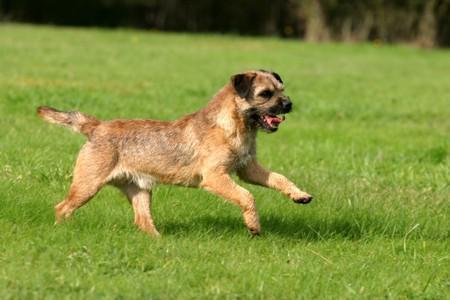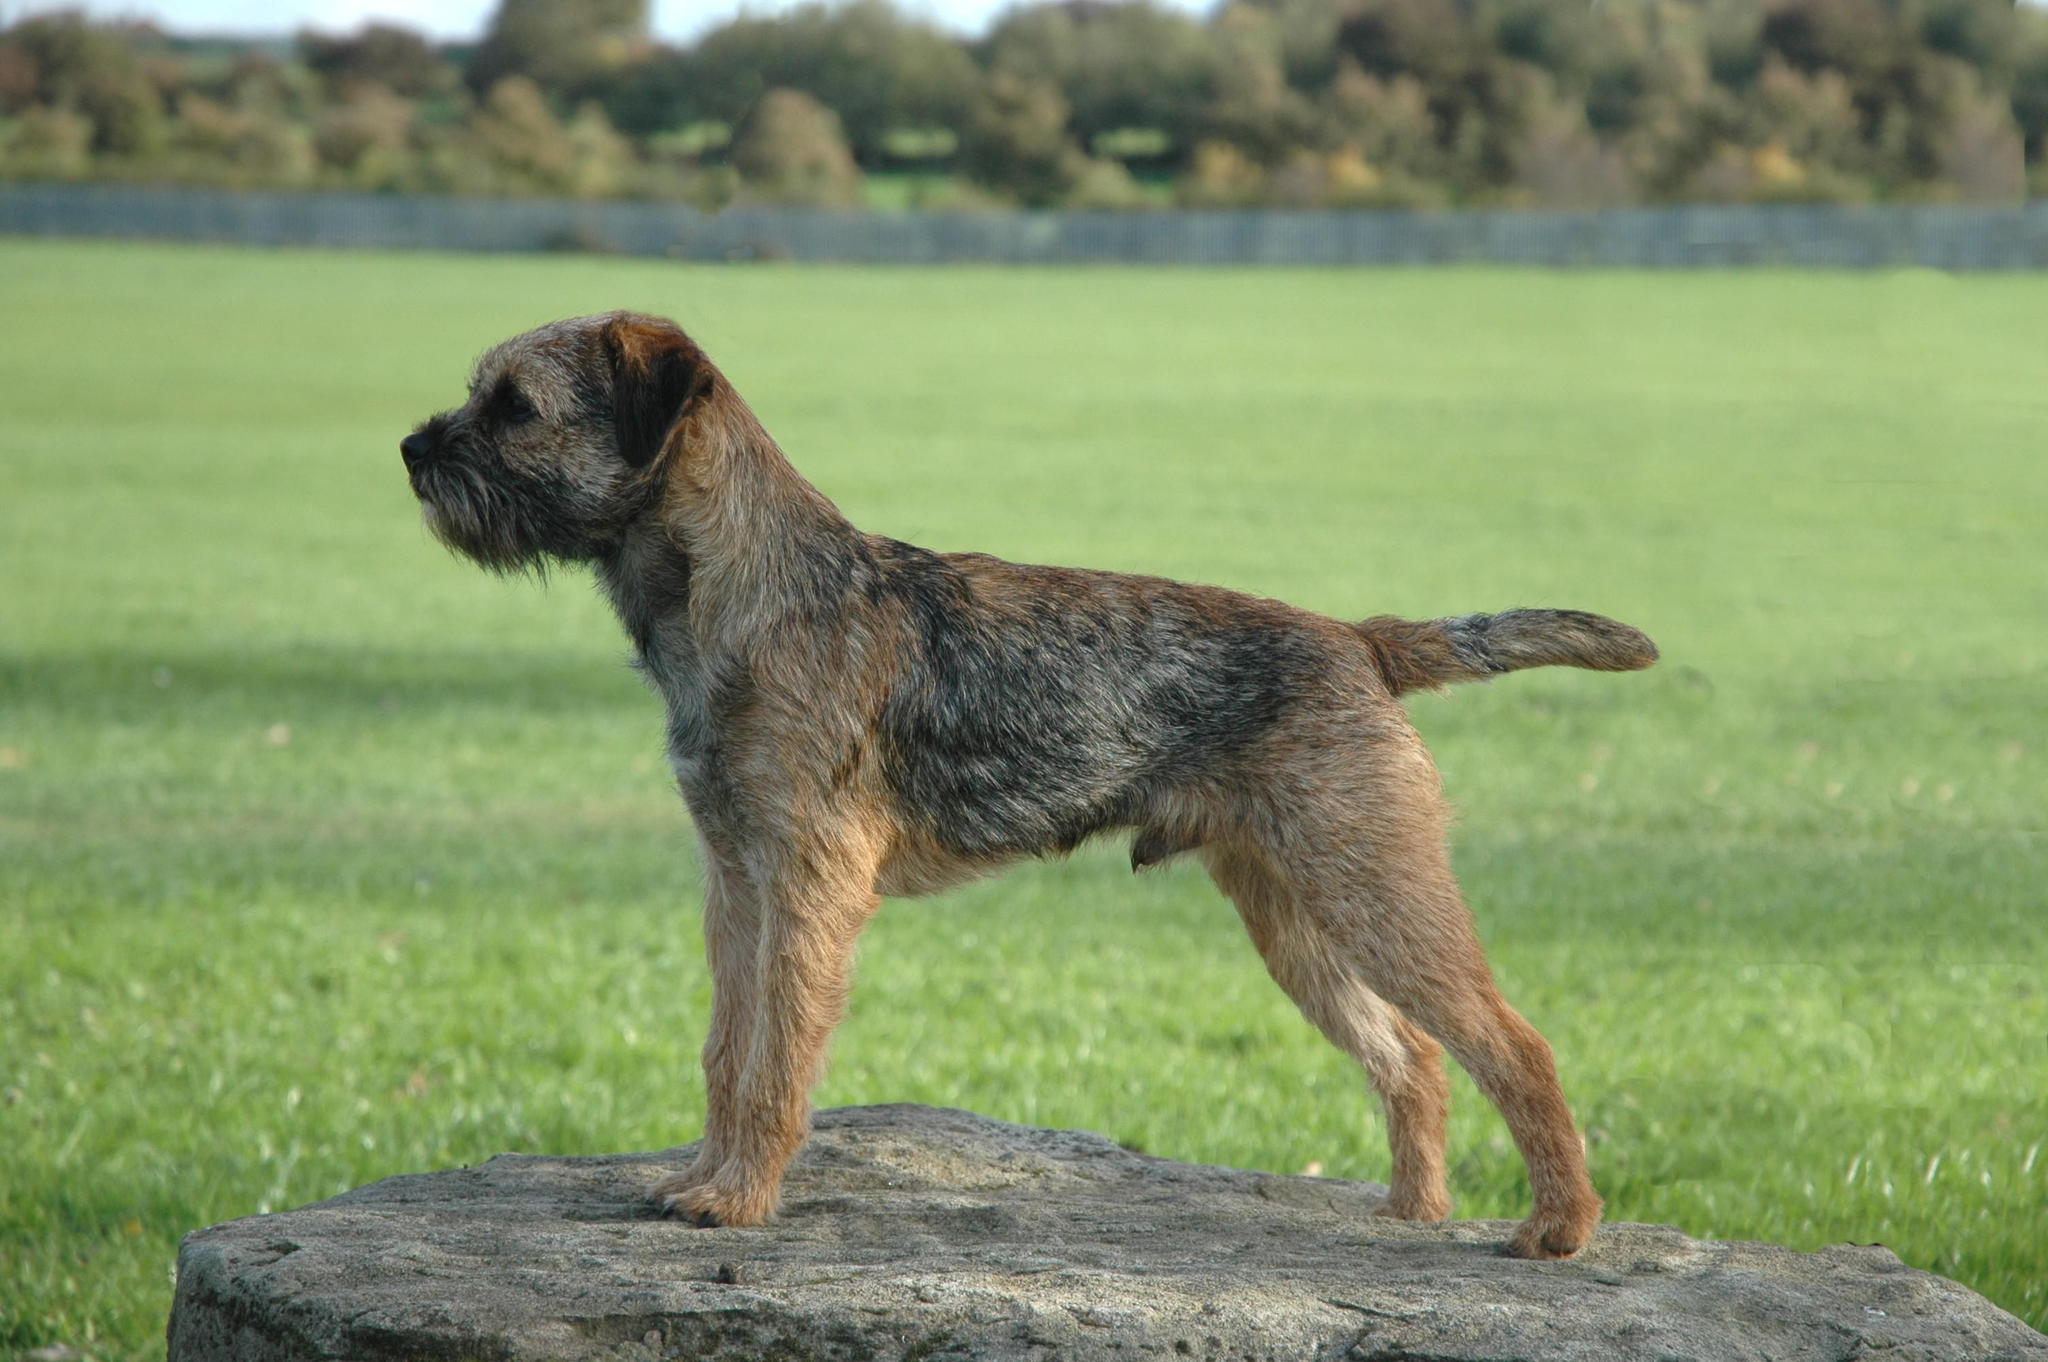The first image is the image on the left, the second image is the image on the right. Given the left and right images, does the statement "Both images show a dog running in the grass." hold true? Answer yes or no. No. The first image is the image on the left, the second image is the image on the right. Examine the images to the left and right. Is the description "The dog in the image on the right is not running." accurate? Answer yes or no. Yes. 